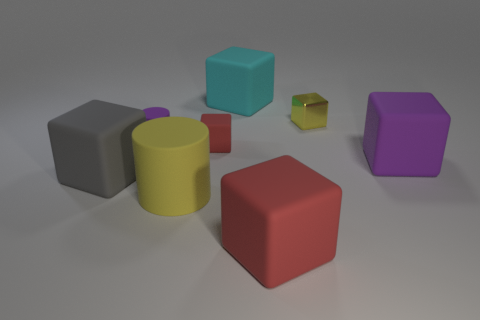What material is the large object that is right of the large yellow rubber cylinder and in front of the gray matte thing?
Offer a very short reply. Rubber. Are there any large rubber cylinders in front of the purple rubber thing to the left of the large purple rubber block?
Your answer should be very brief. Yes. Is the material of the large red object the same as the small yellow block?
Keep it short and to the point. No. There is a matte object that is both in front of the big gray rubber thing and right of the big rubber cylinder; what is its shape?
Provide a short and direct response. Cube. There is a yellow rubber object that is to the left of the big purple matte object behind the large red block; how big is it?
Make the answer very short. Large. What number of big cyan things are the same shape as the big purple rubber thing?
Offer a very short reply. 1. Is the color of the large matte cylinder the same as the shiny block?
Provide a short and direct response. Yes. Is there a thing that has the same color as the large matte cylinder?
Provide a succinct answer. Yes. Does the yellow thing that is right of the cyan block have the same material as the yellow thing to the left of the large cyan rubber thing?
Your answer should be very brief. No. The small shiny thing is what color?
Give a very brief answer. Yellow. 